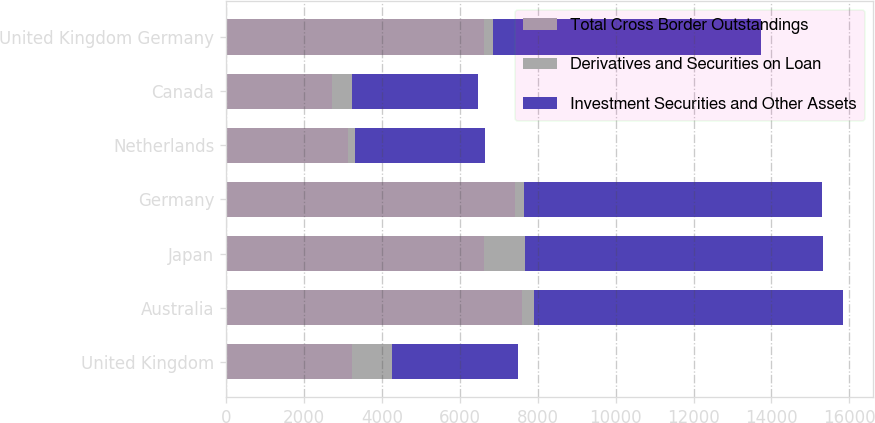Convert chart. <chart><loc_0><loc_0><loc_500><loc_500><stacked_bar_chart><ecel><fcel>United Kingdom<fcel>Australia<fcel>Japan<fcel>Germany<fcel>Netherlands<fcel>Canada<fcel>United Kingdom Germany<nl><fcel>Total Cross Border Outstandings<fcel>3230<fcel>7585<fcel>6625<fcel>7426<fcel>3130<fcel>2730<fcel>6626<nl><fcel>Derivatives and Securities on Loan<fcel>1033<fcel>328<fcel>1041<fcel>220<fcel>188<fcel>500<fcel>236<nl><fcel>Investment Securities and Other Assets<fcel>3230<fcel>7913<fcel>7666<fcel>7646<fcel>3318<fcel>3230<fcel>6862<nl></chart> 